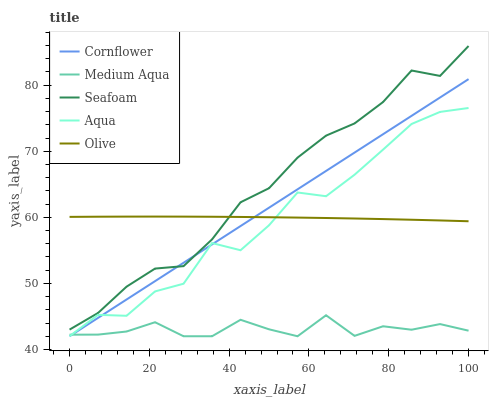Does Medium Aqua have the minimum area under the curve?
Answer yes or no. Yes. Does Seafoam have the maximum area under the curve?
Answer yes or no. Yes. Does Cornflower have the minimum area under the curve?
Answer yes or no. No. Does Cornflower have the maximum area under the curve?
Answer yes or no. No. Is Cornflower the smoothest?
Answer yes or no. Yes. Is Aqua the roughest?
Answer yes or no. Yes. Is Medium Aqua the smoothest?
Answer yes or no. No. Is Medium Aqua the roughest?
Answer yes or no. No. Does Cornflower have the lowest value?
Answer yes or no. Yes. Does Seafoam have the lowest value?
Answer yes or no. No. Does Seafoam have the highest value?
Answer yes or no. Yes. Does Cornflower have the highest value?
Answer yes or no. No. Is Medium Aqua less than Seafoam?
Answer yes or no. Yes. Is Seafoam greater than Aqua?
Answer yes or no. Yes. Does Aqua intersect Medium Aqua?
Answer yes or no. Yes. Is Aqua less than Medium Aqua?
Answer yes or no. No. Is Aqua greater than Medium Aqua?
Answer yes or no. No. Does Medium Aqua intersect Seafoam?
Answer yes or no. No. 